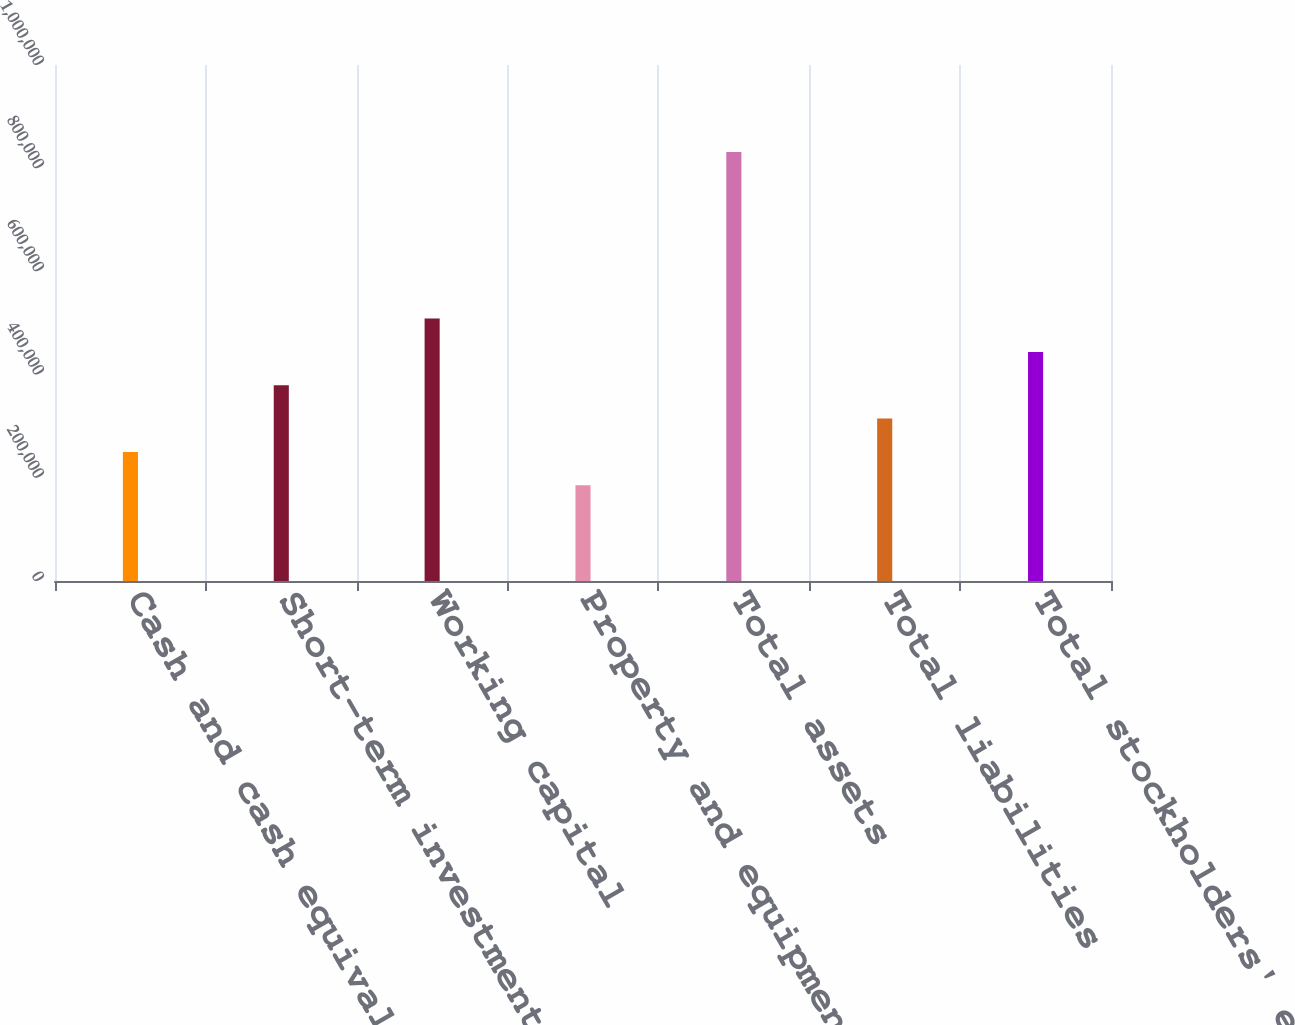Convert chart. <chart><loc_0><loc_0><loc_500><loc_500><bar_chart><fcel>Cash and cash equivalents<fcel>Short-term investments<fcel>Working capital<fcel>Property and equipment net<fcel>Total assets<fcel>Total liabilities<fcel>Total stockholders' equity<nl><fcel>250173<fcel>379372<fcel>508571<fcel>185574<fcel>831568<fcel>314773<fcel>443972<nl></chart> 